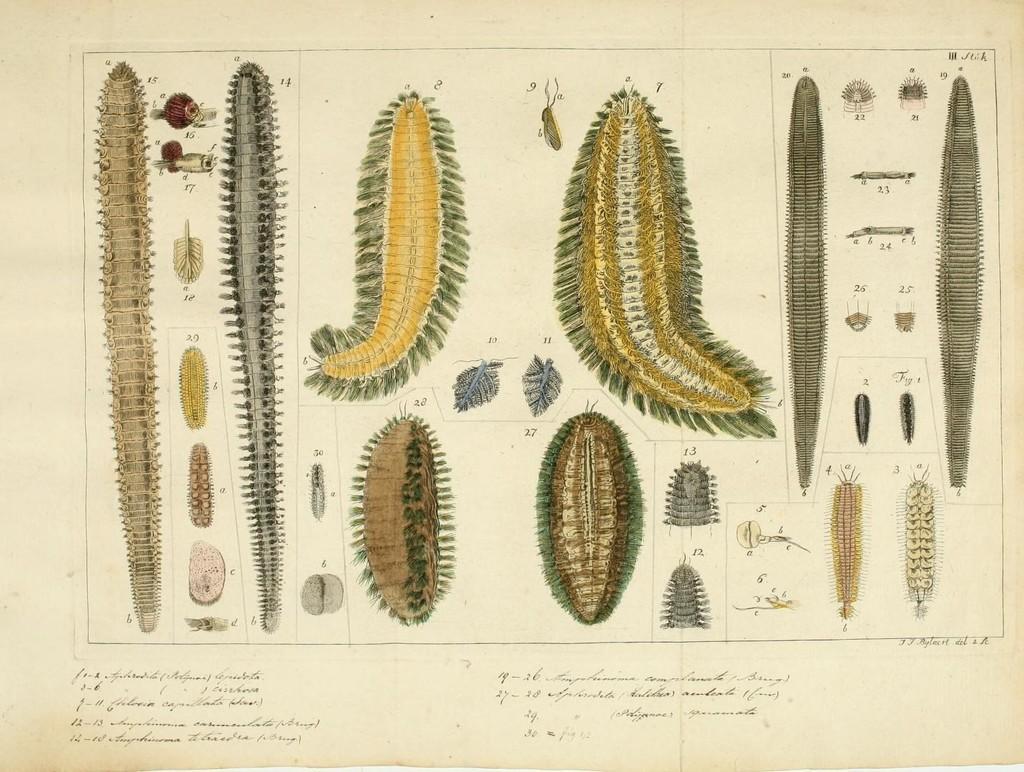Please provide a concise description of this image. In this picture, we see the drawings of the insects or an animal. I think this image describes the life cycle of the caterpillar. At the bottom of the picture, we see some text written. In the background, it is white in color. This is drawn on the paper. 